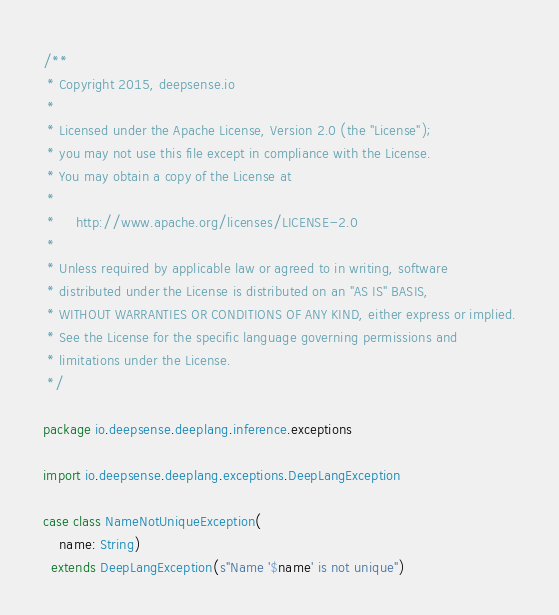Convert code to text. <code><loc_0><loc_0><loc_500><loc_500><_Scala_>/**
 * Copyright 2015, deepsense.io
 *
 * Licensed under the Apache License, Version 2.0 (the "License");
 * you may not use this file except in compliance with the License.
 * You may obtain a copy of the License at
 *
 *     http://www.apache.org/licenses/LICENSE-2.0
 *
 * Unless required by applicable law or agreed to in writing, software
 * distributed under the License is distributed on an "AS IS" BASIS,
 * WITHOUT WARRANTIES OR CONDITIONS OF ANY KIND, either express or implied.
 * See the License for the specific language governing permissions and
 * limitations under the License.
 */

package io.deepsense.deeplang.inference.exceptions

import io.deepsense.deeplang.exceptions.DeepLangException

case class NameNotUniqueException(
    name: String)
  extends DeepLangException(s"Name '$name' is not unique")
</code> 